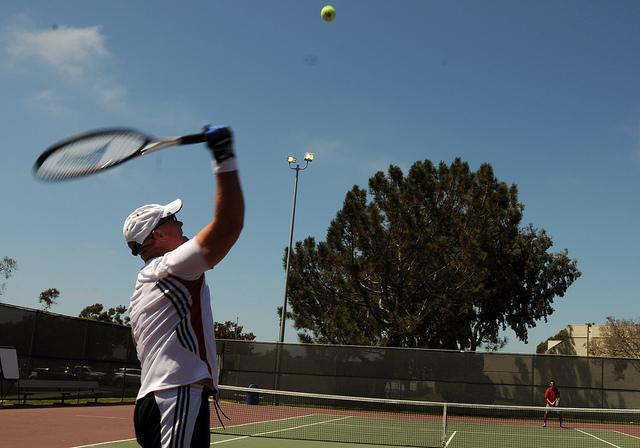How many people are on the court?
Give a very brief answer. 2. How many people can you see?
Give a very brief answer. 1. 